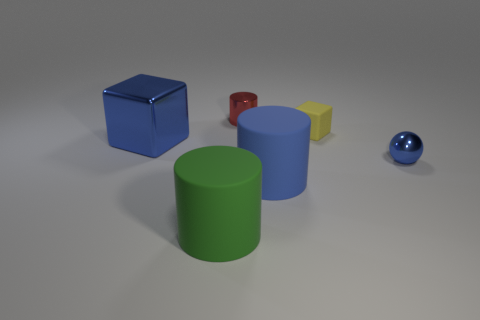What is the size of the blue metal thing to the right of the yellow rubber object?
Your answer should be compact. Small. How many red metallic things have the same shape as the green thing?
Ensure brevity in your answer.  1. The blue thing that is on the left side of the small blue sphere and in front of the large shiny block is made of what material?
Your answer should be compact. Rubber. Are the tiny red object and the blue cylinder made of the same material?
Provide a short and direct response. No. How many blue shiny balls are there?
Provide a succinct answer. 1. There is a big thing that is behind the blue thing that is to the right of the cube to the right of the shiny block; what is its color?
Make the answer very short. Blue. Is the color of the small cube the same as the tiny metallic ball?
Your answer should be compact. No. How many rubber things are both left of the tiny matte object and behind the large green thing?
Provide a short and direct response. 1. How many rubber objects are small yellow cubes or small balls?
Ensure brevity in your answer.  1. What material is the large thing behind the thing to the right of the small yellow matte object?
Give a very brief answer. Metal. 